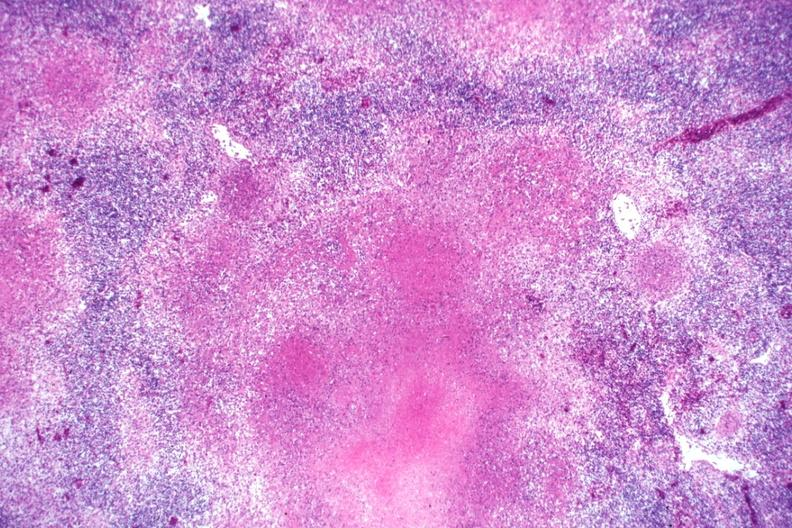s excellent example present?
Answer the question using a single word or phrase. No 